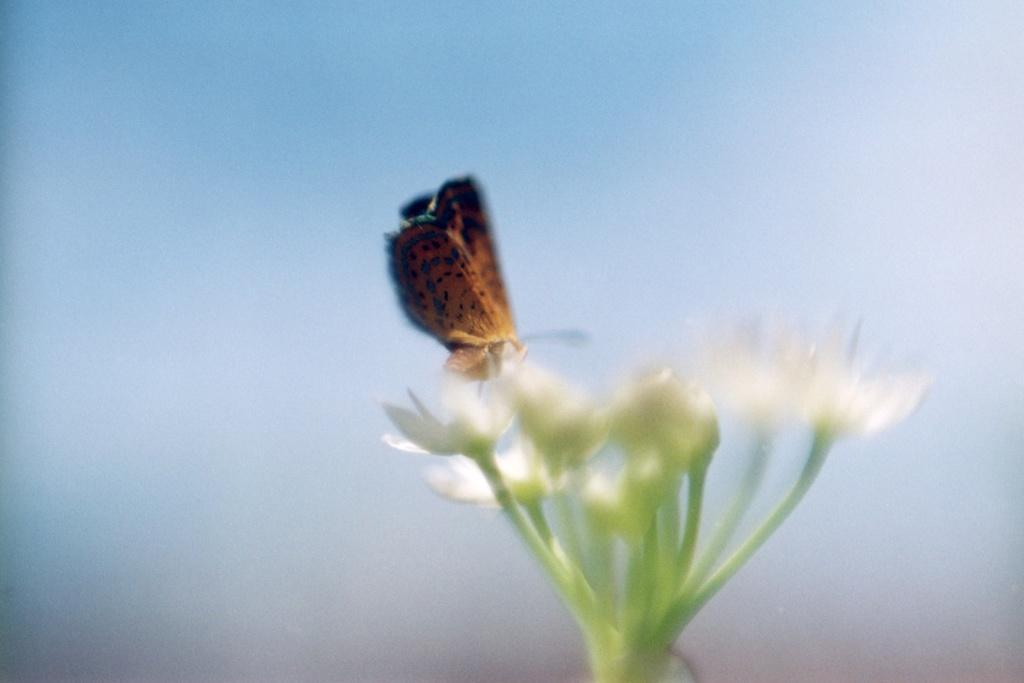Could you give a brief overview of what you see in this image? In the image there is a butterfly on a flower. 